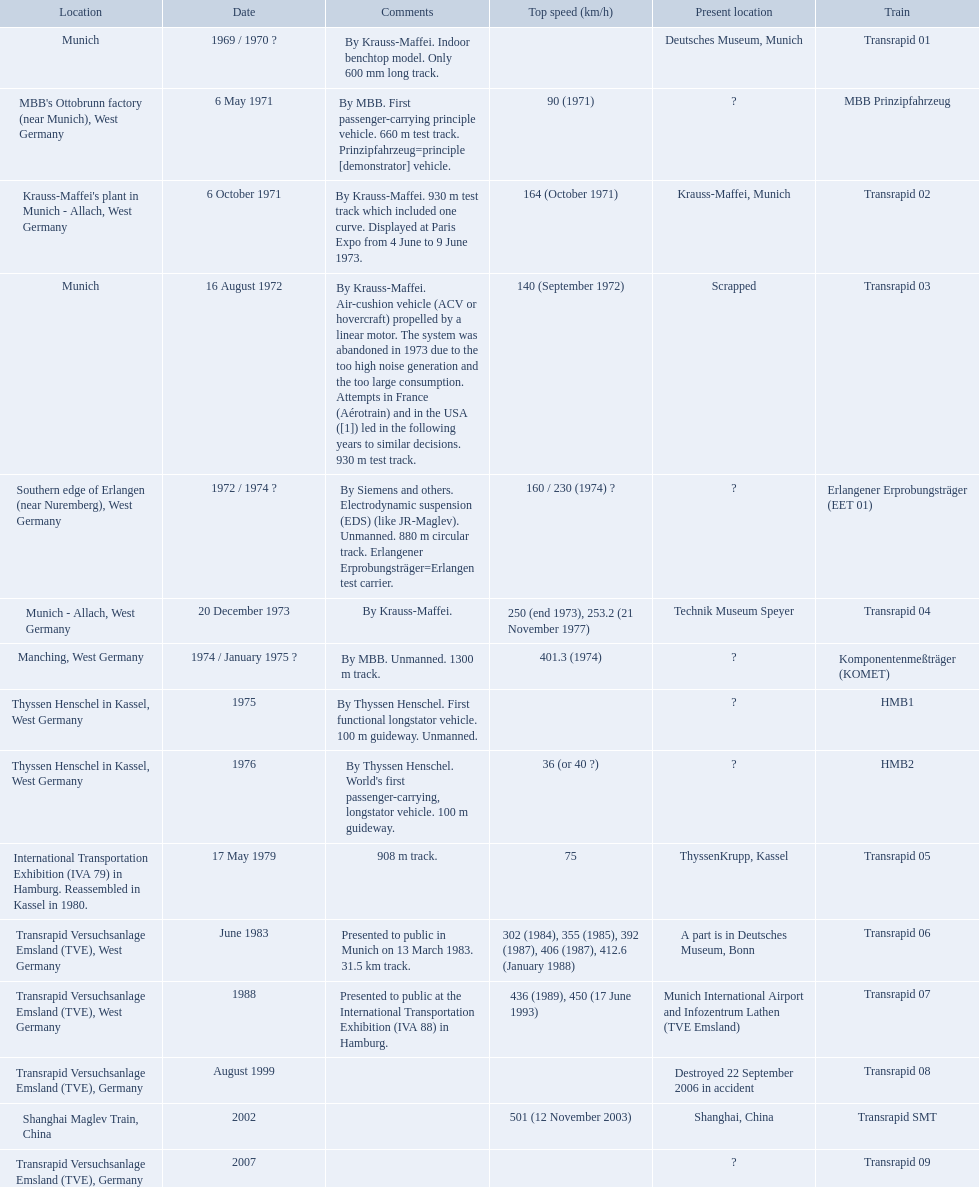What are the names of each transrapid train? Transrapid 01, MBB Prinzipfahrzeug, Transrapid 02, Transrapid 03, Erlangener Erprobungsträger (EET 01), Transrapid 04, Komponentenmeßträger (KOMET), HMB1, HMB2, Transrapid 05, Transrapid 06, Transrapid 07, Transrapid 08, Transrapid SMT, Transrapid 09. What are their listed top speeds? 90 (1971), 164 (October 1971), 140 (September 1972), 160 / 230 (1974) ?, 250 (end 1973), 253.2 (21 November 1977), 401.3 (1974), 36 (or 40 ?), 75, 302 (1984), 355 (1985), 392 (1987), 406 (1987), 412.6 (January 1988), 436 (1989), 450 (17 June 1993), 501 (12 November 2003). And which train operates at the fastest speed? Transrapid SMT. 